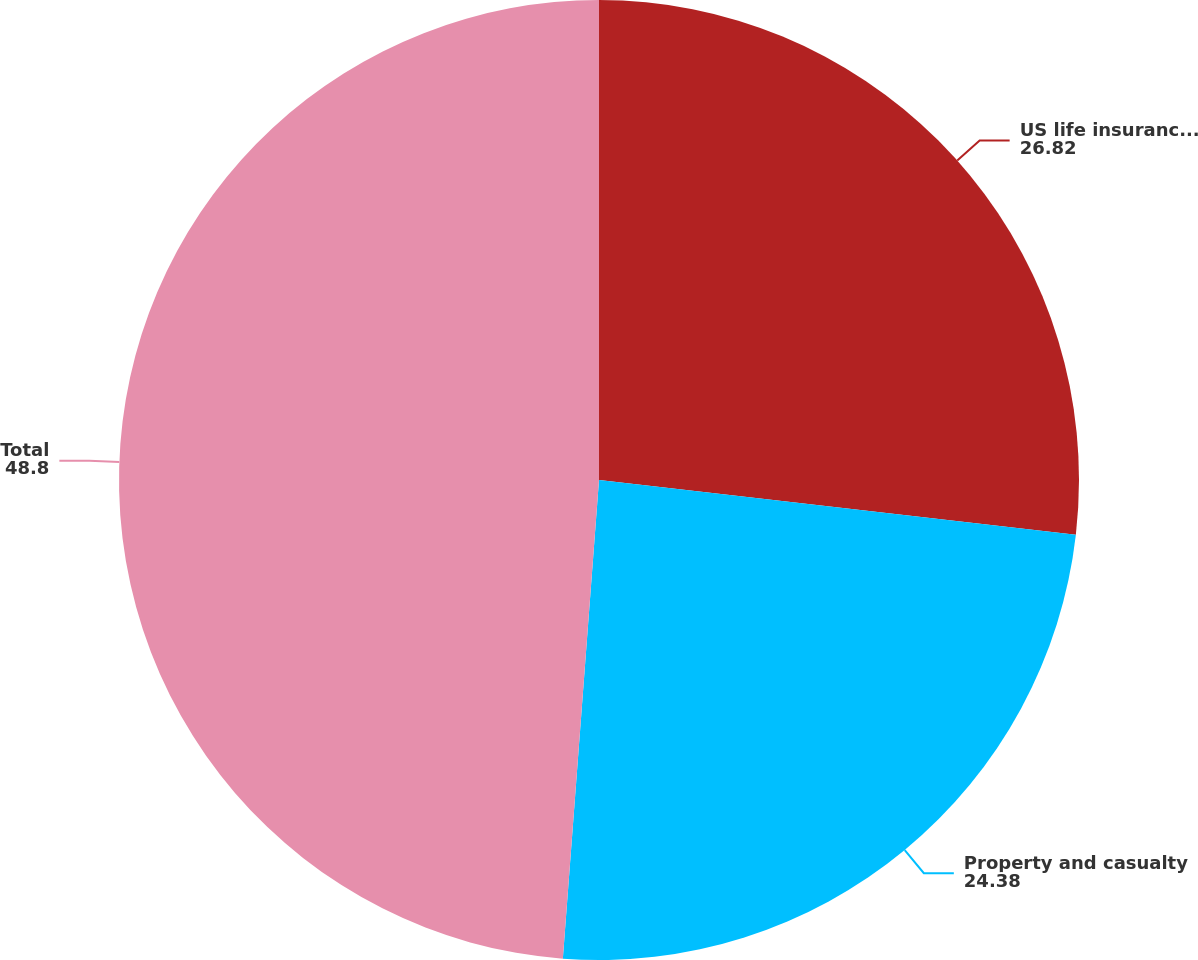Convert chart to OTSL. <chart><loc_0><loc_0><loc_500><loc_500><pie_chart><fcel>US life insurance subsidiaries<fcel>Property and casualty<fcel>Total<nl><fcel>26.82%<fcel>24.38%<fcel>48.8%<nl></chart> 